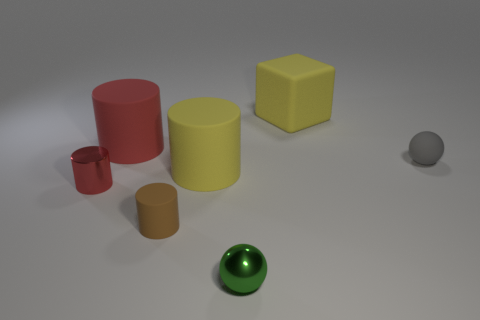There is a gray matte object that is right of the tiny object to the left of the small brown matte cylinder; are there any tiny gray objects that are behind it?
Provide a short and direct response. No. How many rubber things are big cyan spheres or cylinders?
Keep it short and to the point. 3. What number of other things are the same shape as the big red object?
Give a very brief answer. 3. Is the number of large green metal balls greater than the number of large yellow blocks?
Provide a succinct answer. No. There is a ball that is in front of the rubber thing right of the large yellow object on the right side of the green shiny sphere; what size is it?
Make the answer very short. Small. There is a red thing in front of the tiny gray ball; what is its size?
Provide a succinct answer. Small. How many things are yellow rubber cylinders or small balls on the left side of the small gray matte ball?
Keep it short and to the point. 2. What number of other things are there of the same size as the green metal ball?
Your answer should be very brief. 3. There is a green thing that is the same shape as the tiny gray object; what is it made of?
Keep it short and to the point. Metal. Is the number of large yellow cylinders that are in front of the yellow rubber block greater than the number of big green rubber balls?
Give a very brief answer. Yes. 